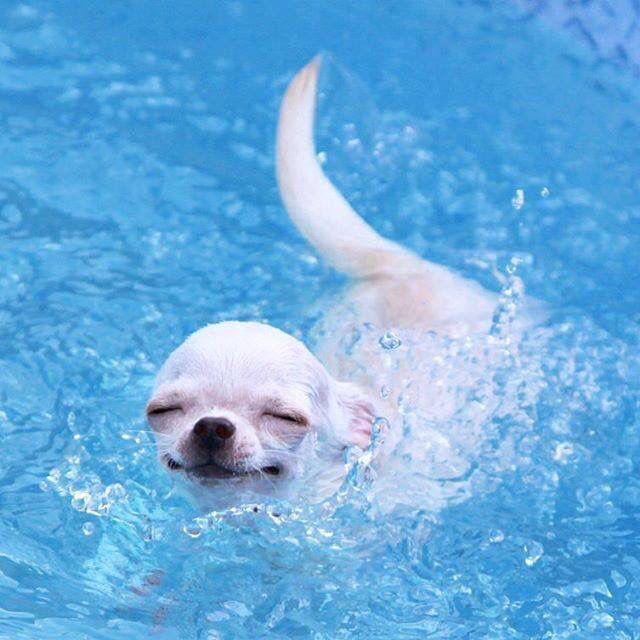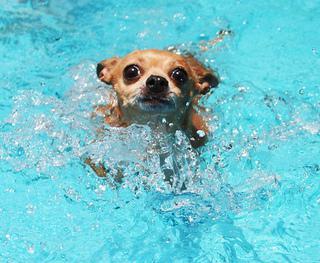The first image is the image on the left, the second image is the image on the right. Analyze the images presented: Is the assertion "An image shows a small dog standing on top of a floating raft-type item." valid? Answer yes or no. No. The first image is the image on the left, the second image is the image on the right. Analyze the images presented: Is the assertion "A dog is in a swimming pool with a floating device." valid? Answer yes or no. No. 